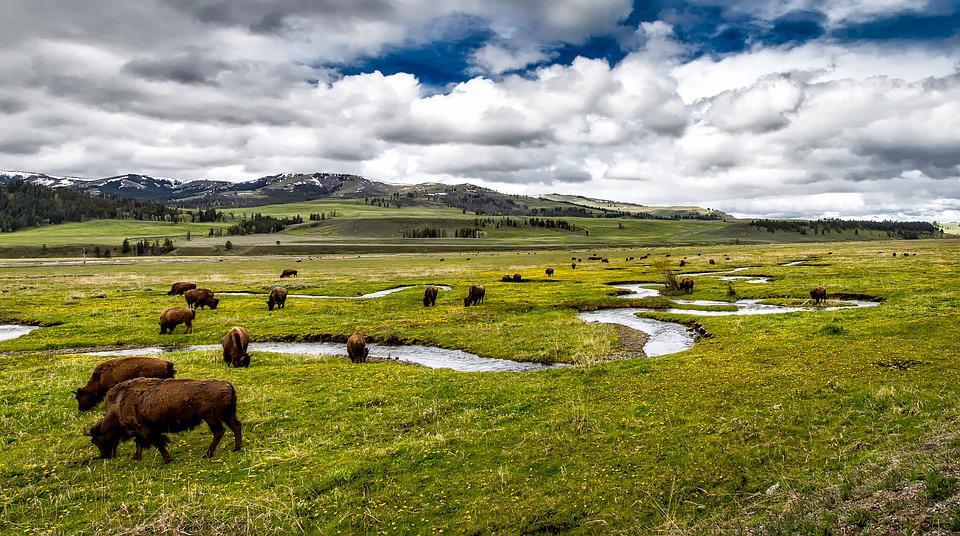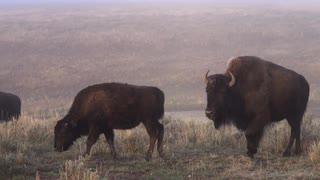The first image is the image on the left, the second image is the image on the right. Analyze the images presented: Is the assertion "Several buffalo are standing in front of channels of water in a green field in one image." valid? Answer yes or no. Yes. The first image is the image on the left, the second image is the image on the right. Given the left and right images, does the statement "In at least one image there are three bulls turned left grazing." hold true? Answer yes or no. Yes. 